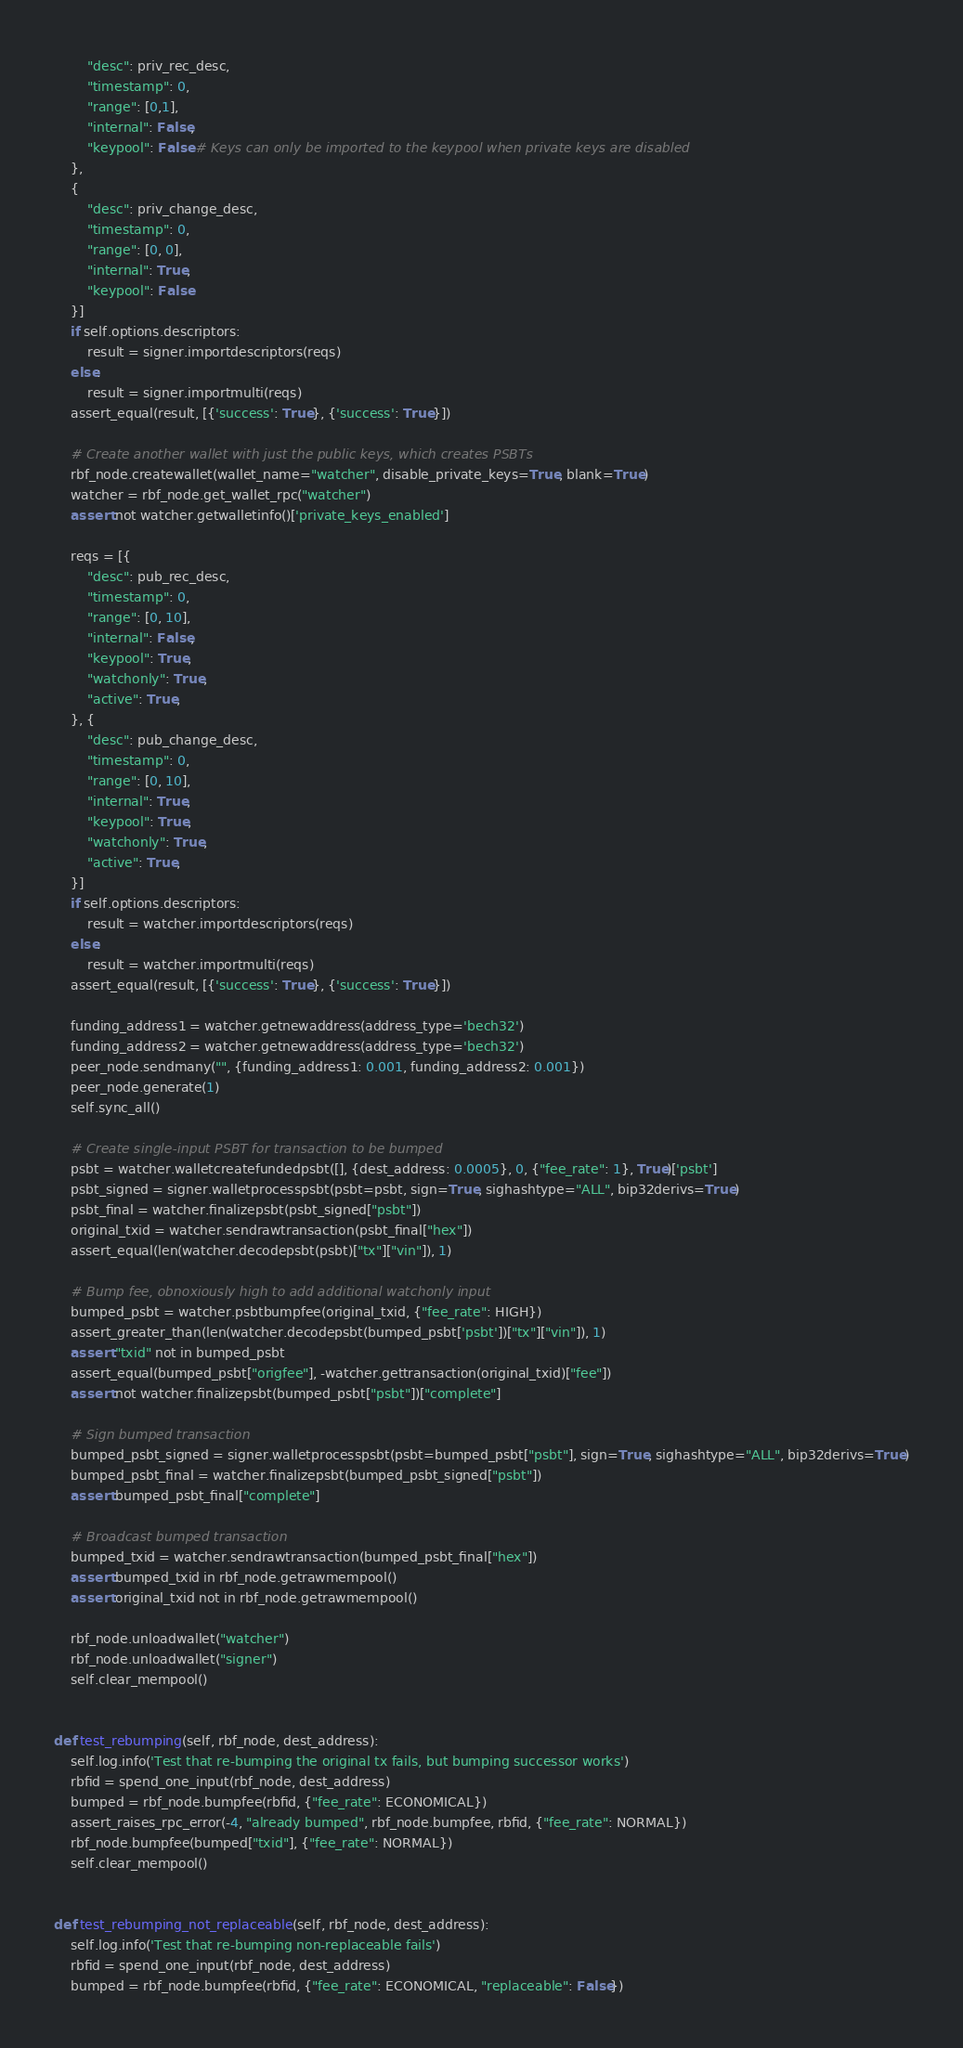<code> <loc_0><loc_0><loc_500><loc_500><_Python_>        "desc": priv_rec_desc,
        "timestamp": 0,
        "range": [0,1],
        "internal": False,
        "keypool": False # Keys can only be imported to the keypool when private keys are disabled
    },
    {
        "desc": priv_change_desc,
        "timestamp": 0,
        "range": [0, 0],
        "internal": True,
        "keypool": False
    }]
    if self.options.descriptors:
        result = signer.importdescriptors(reqs)
    else:
        result = signer.importmulti(reqs)
    assert_equal(result, [{'success': True}, {'success': True}])

    # Create another wallet with just the public keys, which creates PSBTs
    rbf_node.createwallet(wallet_name="watcher", disable_private_keys=True, blank=True)
    watcher = rbf_node.get_wallet_rpc("watcher")
    assert not watcher.getwalletinfo()['private_keys_enabled']

    reqs = [{
        "desc": pub_rec_desc,
        "timestamp": 0,
        "range": [0, 10],
        "internal": False,
        "keypool": True,
        "watchonly": True,
        "active": True,
    }, {
        "desc": pub_change_desc,
        "timestamp": 0,
        "range": [0, 10],
        "internal": True,
        "keypool": True,
        "watchonly": True,
        "active": True,
    }]
    if self.options.descriptors:
        result = watcher.importdescriptors(reqs)
    else:
        result = watcher.importmulti(reqs)
    assert_equal(result, [{'success': True}, {'success': True}])

    funding_address1 = watcher.getnewaddress(address_type='bech32')
    funding_address2 = watcher.getnewaddress(address_type='bech32')
    peer_node.sendmany("", {funding_address1: 0.001, funding_address2: 0.001})
    peer_node.generate(1)
    self.sync_all()

    # Create single-input PSBT for transaction to be bumped
    psbt = watcher.walletcreatefundedpsbt([], {dest_address: 0.0005}, 0, {"fee_rate": 1}, True)['psbt']
    psbt_signed = signer.walletprocesspsbt(psbt=psbt, sign=True, sighashtype="ALL", bip32derivs=True)
    psbt_final = watcher.finalizepsbt(psbt_signed["psbt"])
    original_txid = watcher.sendrawtransaction(psbt_final["hex"])
    assert_equal(len(watcher.decodepsbt(psbt)["tx"]["vin"]), 1)

    # Bump fee, obnoxiously high to add additional watchonly input
    bumped_psbt = watcher.psbtbumpfee(original_txid, {"fee_rate": HIGH})
    assert_greater_than(len(watcher.decodepsbt(bumped_psbt['psbt'])["tx"]["vin"]), 1)
    assert "txid" not in bumped_psbt
    assert_equal(bumped_psbt["origfee"], -watcher.gettransaction(original_txid)["fee"])
    assert not watcher.finalizepsbt(bumped_psbt["psbt"])["complete"]

    # Sign bumped transaction
    bumped_psbt_signed = signer.walletprocesspsbt(psbt=bumped_psbt["psbt"], sign=True, sighashtype="ALL", bip32derivs=True)
    bumped_psbt_final = watcher.finalizepsbt(bumped_psbt_signed["psbt"])
    assert bumped_psbt_final["complete"]

    # Broadcast bumped transaction
    bumped_txid = watcher.sendrawtransaction(bumped_psbt_final["hex"])
    assert bumped_txid in rbf_node.getrawmempool()
    assert original_txid not in rbf_node.getrawmempool()

    rbf_node.unloadwallet("watcher")
    rbf_node.unloadwallet("signer")
    self.clear_mempool()


def test_rebumping(self, rbf_node, dest_address):
    self.log.info('Test that re-bumping the original tx fails, but bumping successor works')
    rbfid = spend_one_input(rbf_node, dest_address)
    bumped = rbf_node.bumpfee(rbfid, {"fee_rate": ECONOMICAL})
    assert_raises_rpc_error(-4, "already bumped", rbf_node.bumpfee, rbfid, {"fee_rate": NORMAL})
    rbf_node.bumpfee(bumped["txid"], {"fee_rate": NORMAL})
    self.clear_mempool()


def test_rebumping_not_replaceable(self, rbf_node, dest_address):
    self.log.info('Test that re-bumping non-replaceable fails')
    rbfid = spend_one_input(rbf_node, dest_address)
    bumped = rbf_node.bumpfee(rbfid, {"fee_rate": ECONOMICAL, "replaceable": False})</code> 